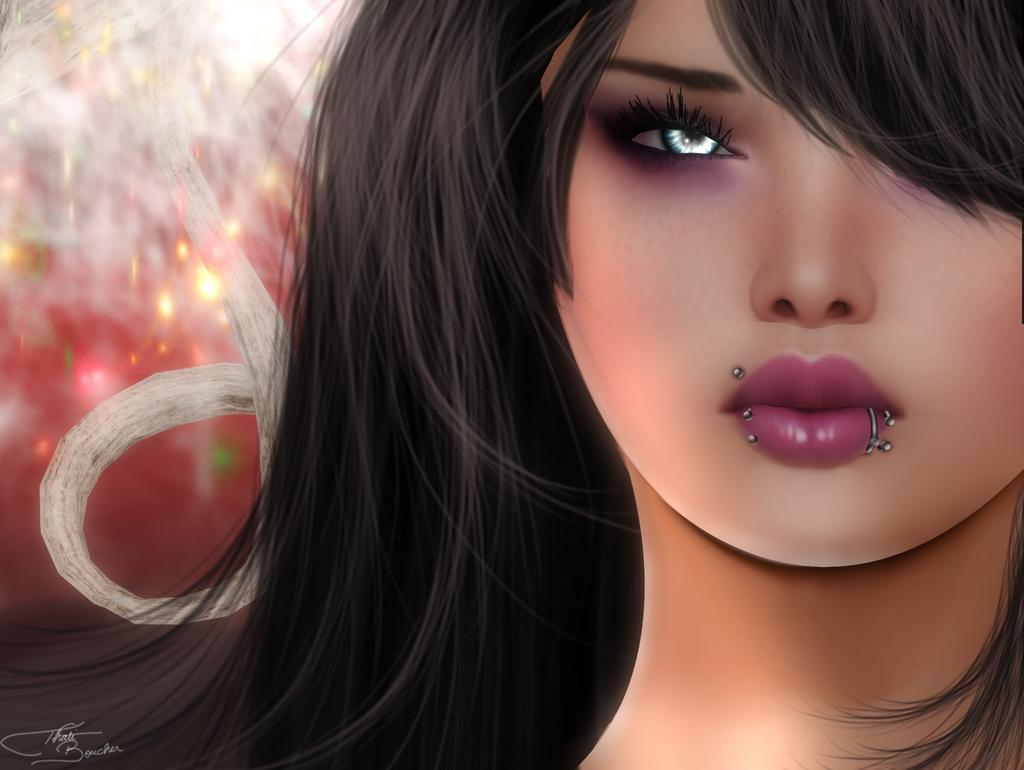What type of art is featured in the image? The image contains a digital art representation. What subject is depicted in the digital art? The digital art depicts a girl. How many letters can be seen in the image? There are no letters present in the image; it features a digital art representation of a girl. What type of animal can be seen interacting with the girl in the image? There is no animal present in the image; it only depicts a girl. 